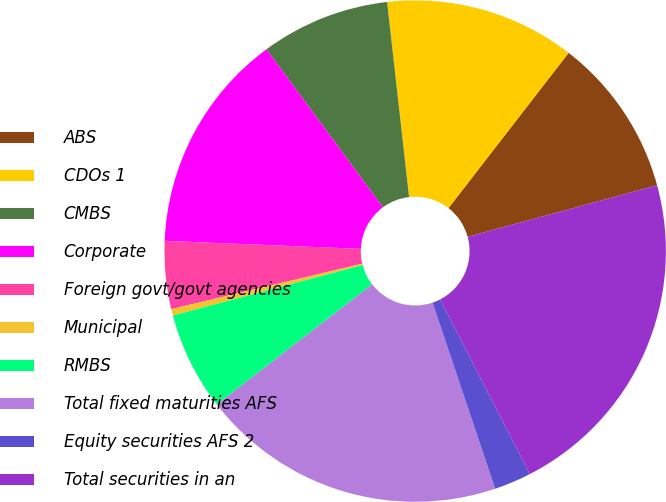<chart> <loc_0><loc_0><loc_500><loc_500><pie_chart><fcel>ABS<fcel>CDOs 1<fcel>CMBS<fcel>Corporate<fcel>Foreign govt/govt agencies<fcel>Municipal<fcel>RMBS<fcel>Total fixed maturities AFS<fcel>Equity securities AFS 2<fcel>Total securities in an<nl><fcel>10.29%<fcel>12.27%<fcel>8.32%<fcel>14.24%<fcel>4.37%<fcel>0.42%<fcel>6.34%<fcel>19.69%<fcel>2.39%<fcel>21.67%<nl></chart> 